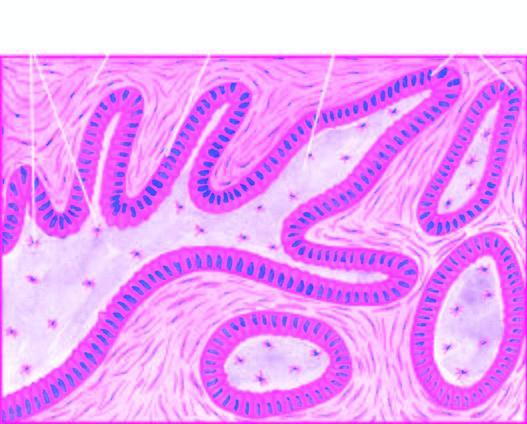what do a few areas show?
Answer the question using a single word or phrase. Central cystic change 